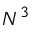<formula> <loc_0><loc_0><loc_500><loc_500>N ^ { 3 }</formula> 